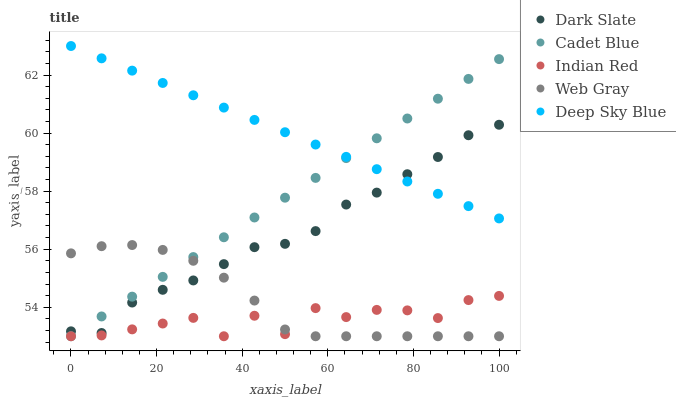Does Indian Red have the minimum area under the curve?
Answer yes or no. Yes. Does Deep Sky Blue have the maximum area under the curve?
Answer yes or no. Yes. Does Cadet Blue have the minimum area under the curve?
Answer yes or no. No. Does Cadet Blue have the maximum area under the curve?
Answer yes or no. No. Is Cadet Blue the smoothest?
Answer yes or no. Yes. Is Indian Red the roughest?
Answer yes or no. Yes. Is Web Gray the smoothest?
Answer yes or no. No. Is Web Gray the roughest?
Answer yes or no. No. Does Cadet Blue have the lowest value?
Answer yes or no. Yes. Does Deep Sky Blue have the lowest value?
Answer yes or no. No. Does Deep Sky Blue have the highest value?
Answer yes or no. Yes. Does Cadet Blue have the highest value?
Answer yes or no. No. Is Indian Red less than Deep Sky Blue?
Answer yes or no. Yes. Is Deep Sky Blue greater than Web Gray?
Answer yes or no. Yes. Does Web Gray intersect Dark Slate?
Answer yes or no. Yes. Is Web Gray less than Dark Slate?
Answer yes or no. No. Is Web Gray greater than Dark Slate?
Answer yes or no. No. Does Indian Red intersect Deep Sky Blue?
Answer yes or no. No. 